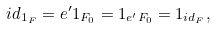Convert formula to latex. <formula><loc_0><loc_0><loc_500><loc_500>i d _ { 1 _ { F } } = e ^ { \prime } 1 _ { F _ { 0 } } = 1 _ { e ^ { \prime } F _ { 0 } } = 1 _ { i d _ { F } } ,</formula> 